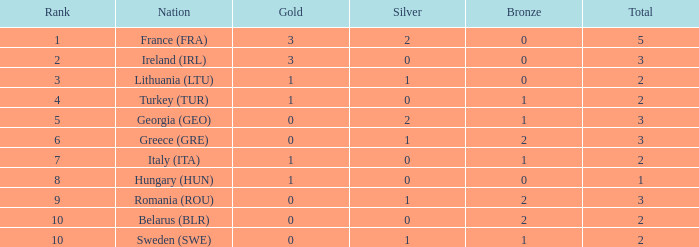What's the total of rank 8 when Silver medals are 0 and gold is more than 1? 0.0. 